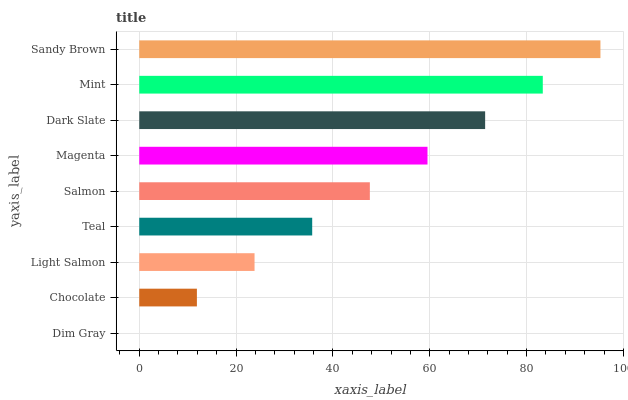Is Dim Gray the minimum?
Answer yes or no. Yes. Is Sandy Brown the maximum?
Answer yes or no. Yes. Is Chocolate the minimum?
Answer yes or no. No. Is Chocolate the maximum?
Answer yes or no. No. Is Chocolate greater than Dim Gray?
Answer yes or no. Yes. Is Dim Gray less than Chocolate?
Answer yes or no. Yes. Is Dim Gray greater than Chocolate?
Answer yes or no. No. Is Chocolate less than Dim Gray?
Answer yes or no. No. Is Salmon the high median?
Answer yes or no. Yes. Is Salmon the low median?
Answer yes or no. Yes. Is Dim Gray the high median?
Answer yes or no. No. Is Sandy Brown the low median?
Answer yes or no. No. 